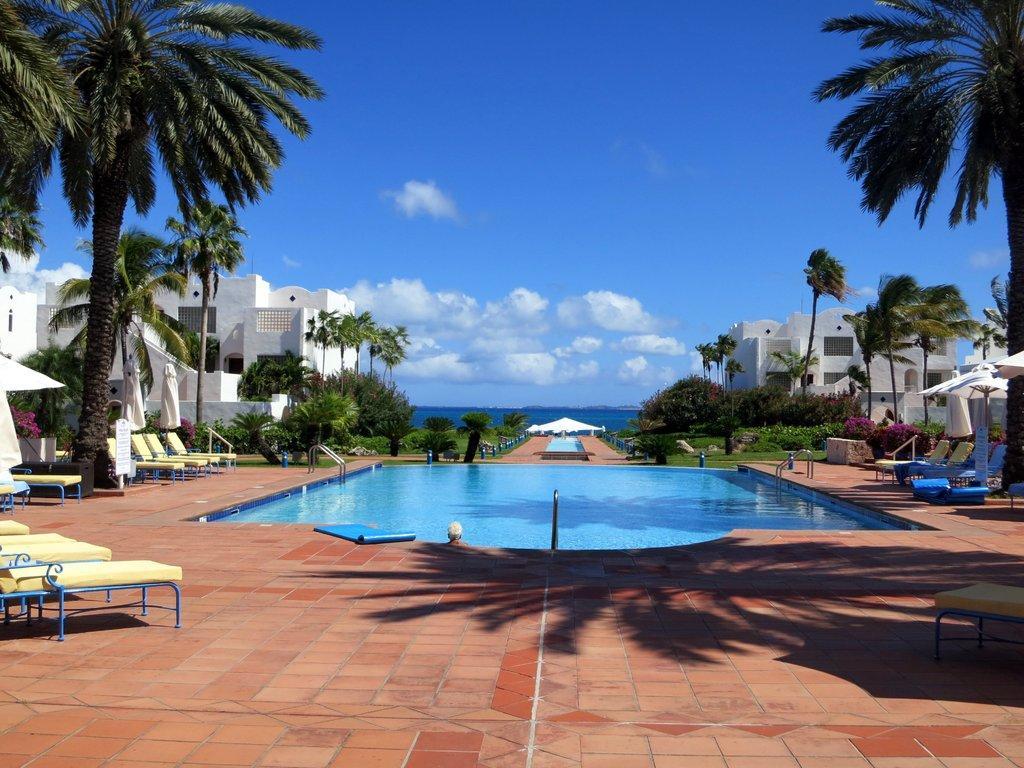Can you describe this image briefly? In the picture it looks like some resort, there is a pool and around the pool there are some chairs and plants, behind the plants there are some buildings and in the background there is a water surface. 